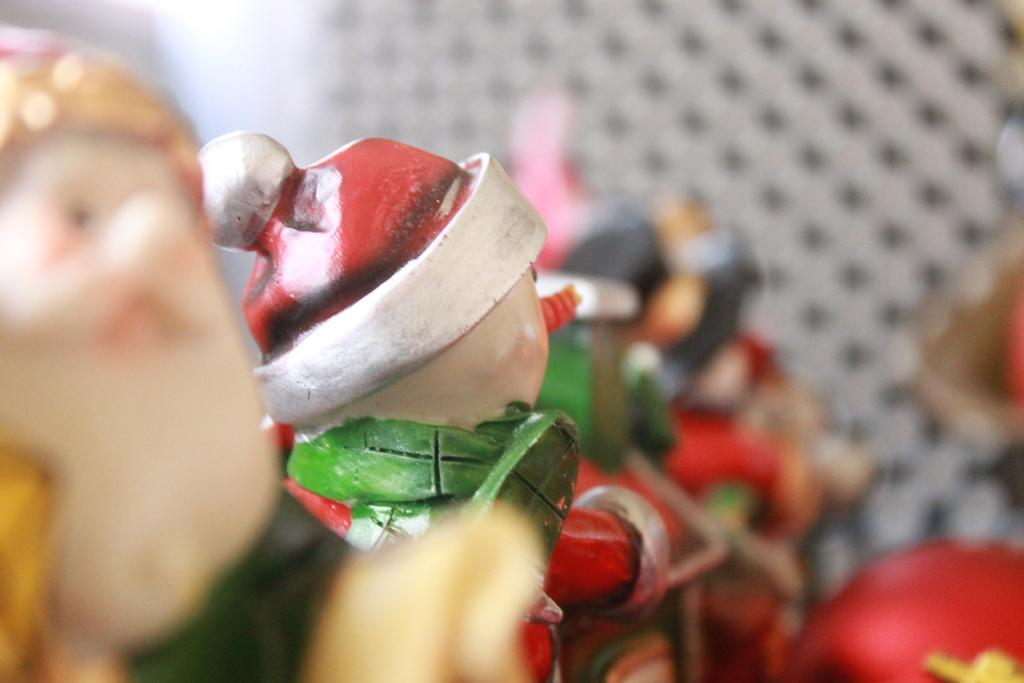What type of objects can be seen in the image? There are dolls in the image. Can you describe the dolls in the image? The provided facts do not include any details about the dolls, so we cannot describe them further. What type of clam is being served by the servant in the image? There is no clam or servant present in the image; it only features dolls. 